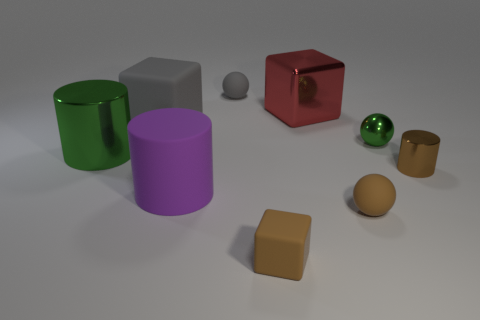Subtract all small brown matte cubes. How many cubes are left? 2 Add 1 green metallic cylinders. How many objects exist? 10 Subtract 1 balls. How many balls are left? 2 Subtract all brown balls. How many balls are left? 2 Subtract all blue spheres. Subtract all purple blocks. How many spheres are left? 3 Subtract all yellow spheres. How many brown cylinders are left? 1 Subtract all big red rubber objects. Subtract all big purple cylinders. How many objects are left? 8 Add 3 brown cylinders. How many brown cylinders are left? 4 Add 7 green spheres. How many green spheres exist? 8 Subtract 1 green cylinders. How many objects are left? 8 